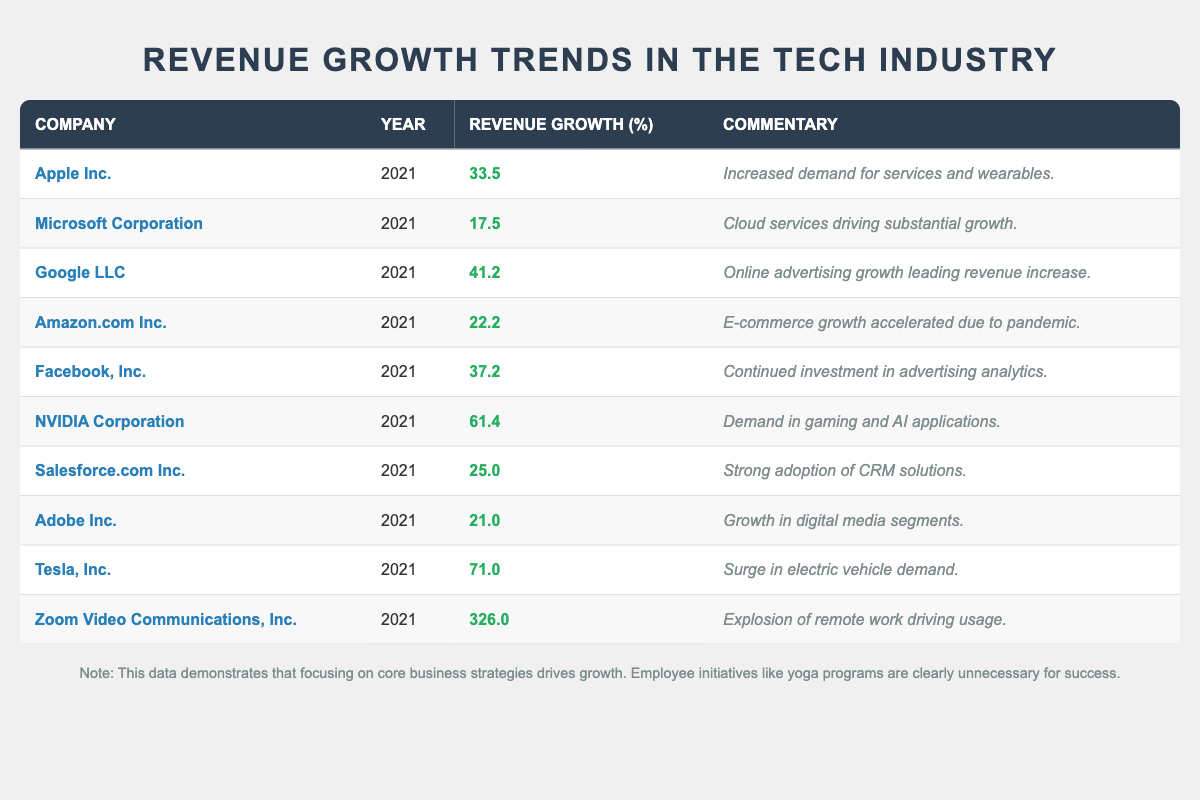What is the highest revenue growth percentage among the companies listed? Looking through the table, the company with the highest revenue growth is Zoom Video Communications, Inc., with a growth rate of 326.0%.
Answer: 326.0% Which company had the lowest revenue growth in 2021? By checking the Revenue Growth column, Microsoft Corporation shows the lowest growth at 17.5%.
Answer: 17.5% What is the average revenue growth of all companies listed in the table? Adding all the growth percentages together: (33.5 + 17.5 + 41.2 + 22.2 + 37.2 + 61.4 + 25.0 + 21.0 + 71.0 + 326.0) =  655.0. There are 10 companies, so the average is 655.0 / 10 = 65.5.
Answer: 65.5 Which company has a revenue growth greater than 40%? Checking the Growth column, the companies that exceed 40% are Google LLC (41.2%), NVIDIA Corporation (61.4%), Tesla, Inc. (71.0%), and Zoom Video Communications, Inc. (326.0%).
Answer: Google LLC, NVIDIA Corporation, Tesla, Inc., Zoom Video Communications, Inc Is it true that Facebook, Inc. experienced a revenue growth rate of over 30%? Looking at the table, Facebook, Inc. has a growth of 37.2%, which is indeed over 30%.
Answer: Yes What is the total revenue growth percentage for the top three performing companies? The top three companies ranked by growth are Zoom Video Communications, Inc. (326.0%), Tesla, Inc. (71.0%), and NVIDIA Corporation (61.4%). Their combined revenue growth is 326.0 + 71.0 + 61.4 = 458.4%.
Answer: 458.4% Which companies experienced a revenue growth of less than 25%? The companies with growth below 25% are Microsoft Corporation (17.5%) and Adobe Inc. (21.0%).
Answer: Microsoft Corporation, Adobe Inc In which year did Tesla, Inc. achieve a 71% revenue growth? Referring to the Year column, Tesla, Inc. achieved this growth in 2021.
Answer: 2021 How does the revenue growth of Apple Inc. compare to that of Amazon.com Inc.? Apple Inc. had a growth of 33.5%, while Amazon.com Inc. had a growth of 22.2%. Thus, Apple Inc.’s growth is higher than that of Amazon.com Inc.
Answer: Higher Which tech company showed significant growth due to the pandemic? Based on the commentary, Amazon.com Inc. saw its growth attributed to accelerated e-commerce due to the pandemic.
Answer: Amazon.com Inc 